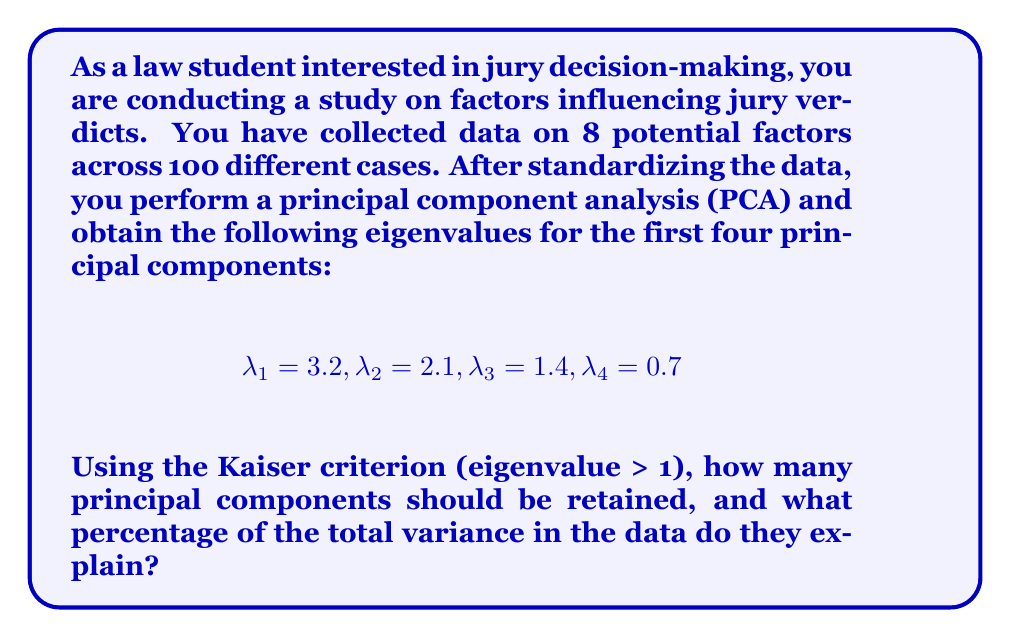Solve this math problem. To solve this problem, we need to follow these steps:

1. Identify the number of principal components to retain based on the Kaiser criterion.
2. Calculate the total variance explained by these components.
3. Calculate the percentage of total variance explained.

Step 1: Identifying principal components to retain
The Kaiser criterion suggests retaining only those principal components with eigenvalues greater than 1. From the given eigenvalues:

$$
\lambda_1 = 3.2 > 1
\lambda_2 = 2.1 > 1
\lambda_3 = 1.4 > 1
\lambda_4 = 0.7 < 1
$$

Therefore, we should retain the first 3 principal components.

Step 2: Calculating total variance explained
In PCA, each eigenvalue represents the amount of variance explained by its corresponding principal component. The total variance explained by the retained components is the sum of their eigenvalues:

$$
\text{Total variance explained} = \lambda_1 + \lambda_2 + \lambda_3 = 3.2 + 2.1 + 1.4 = 6.7
$$

Step 3: Calculating percentage of total variance explained
To calculate the percentage of total variance explained, we need to know the total variance in the dataset. In PCA, the total variance is equal to the number of variables, which in this case is 8 (as mentioned in the question).

The percentage of total variance explained is:

$$
\text{Percentage} = \frac{\text{Total variance explained}}{\text{Total variance}} \times 100\%
$$

$$
= \frac{6.7}{8} \times 100\% = 83.75\%
$$

Therefore, the 3 retained principal components explain 83.75% of the total variance in the data.
Answer: 3 principal components should be retained, explaining 83.75% of the total variance. 